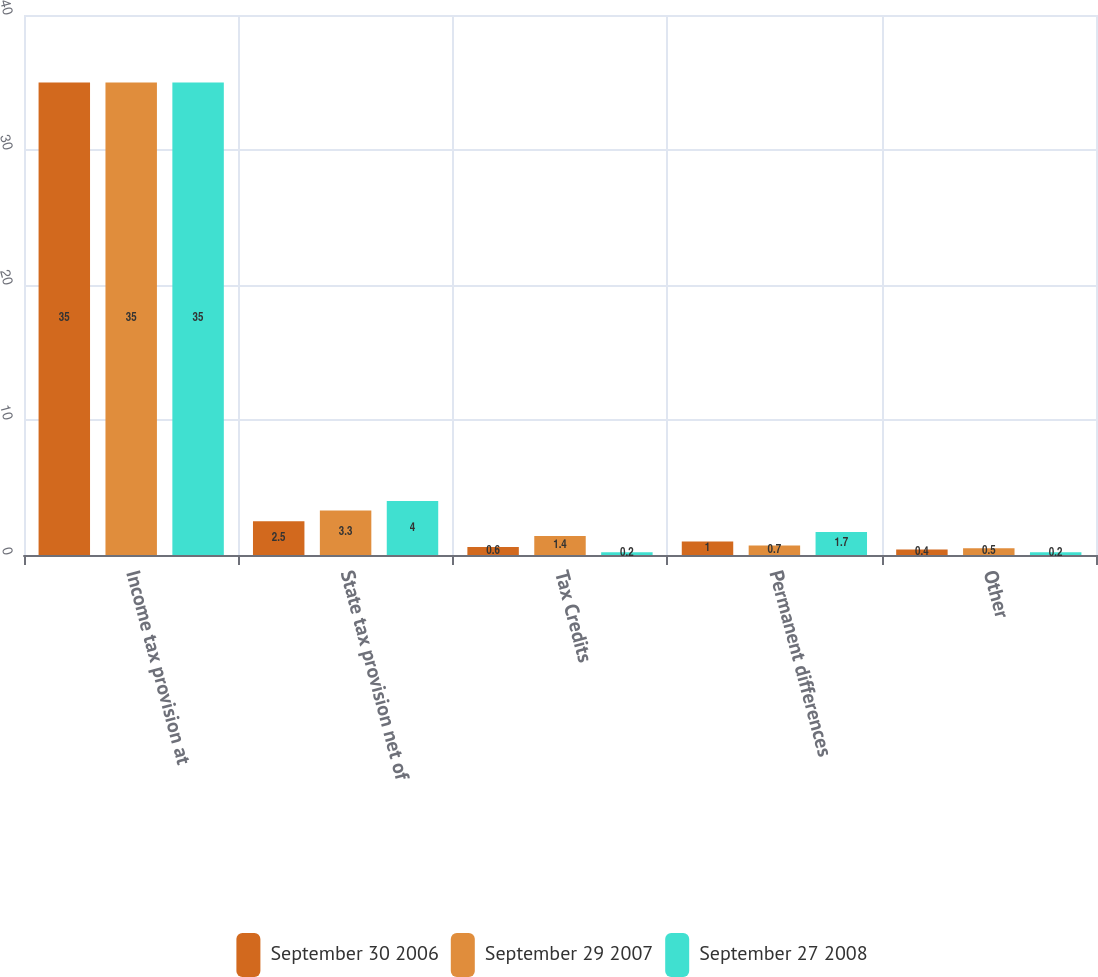<chart> <loc_0><loc_0><loc_500><loc_500><stacked_bar_chart><ecel><fcel>Income tax provision at<fcel>State tax provision net of<fcel>Tax Credits<fcel>Permanent differences<fcel>Other<nl><fcel>September 30 2006<fcel>35<fcel>2.5<fcel>0.6<fcel>1<fcel>0.4<nl><fcel>September 29 2007<fcel>35<fcel>3.3<fcel>1.4<fcel>0.7<fcel>0.5<nl><fcel>September 27 2008<fcel>35<fcel>4<fcel>0.2<fcel>1.7<fcel>0.2<nl></chart> 